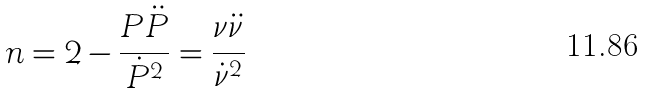<formula> <loc_0><loc_0><loc_500><loc_500>n = 2 - \frac { P \ddot { P } } { \dot { P } ^ { 2 } } = \frac { \nu \ddot { \nu } } { \dot { \nu } ^ { 2 } }</formula> 